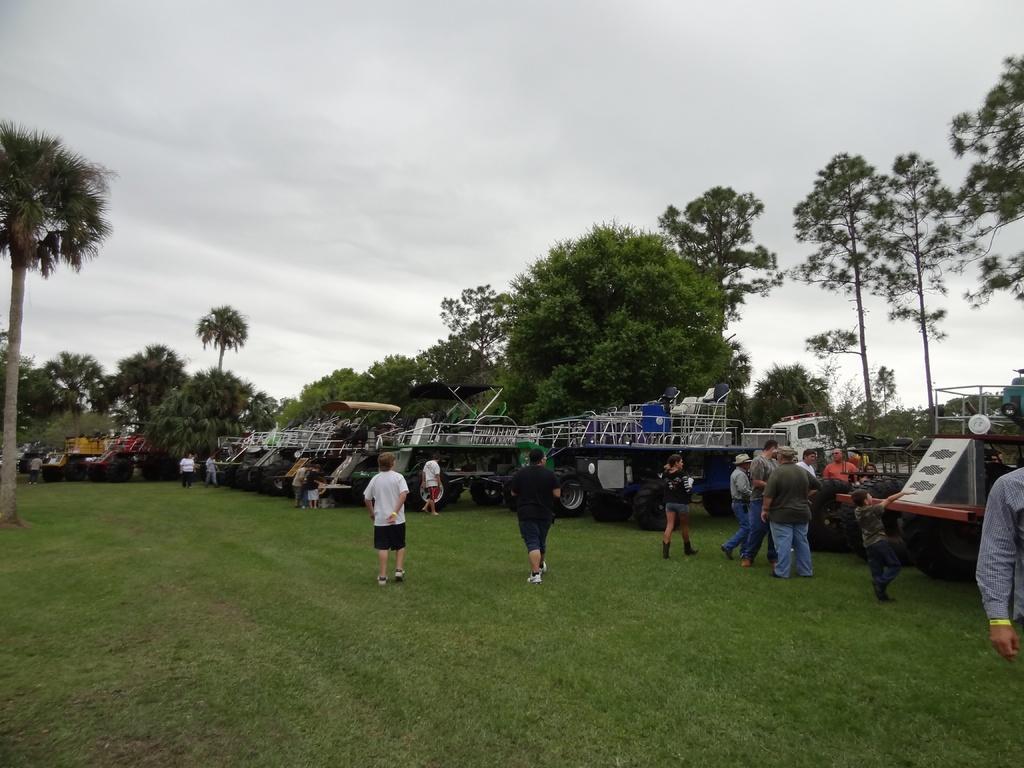How would you summarize this image in a sentence or two? There are some persons standing on a grassy land as we can see at the bottom of this image. There are some vehicles parked beside to these persons. There are some trees in the background, and there is a sky at the top of this image. 